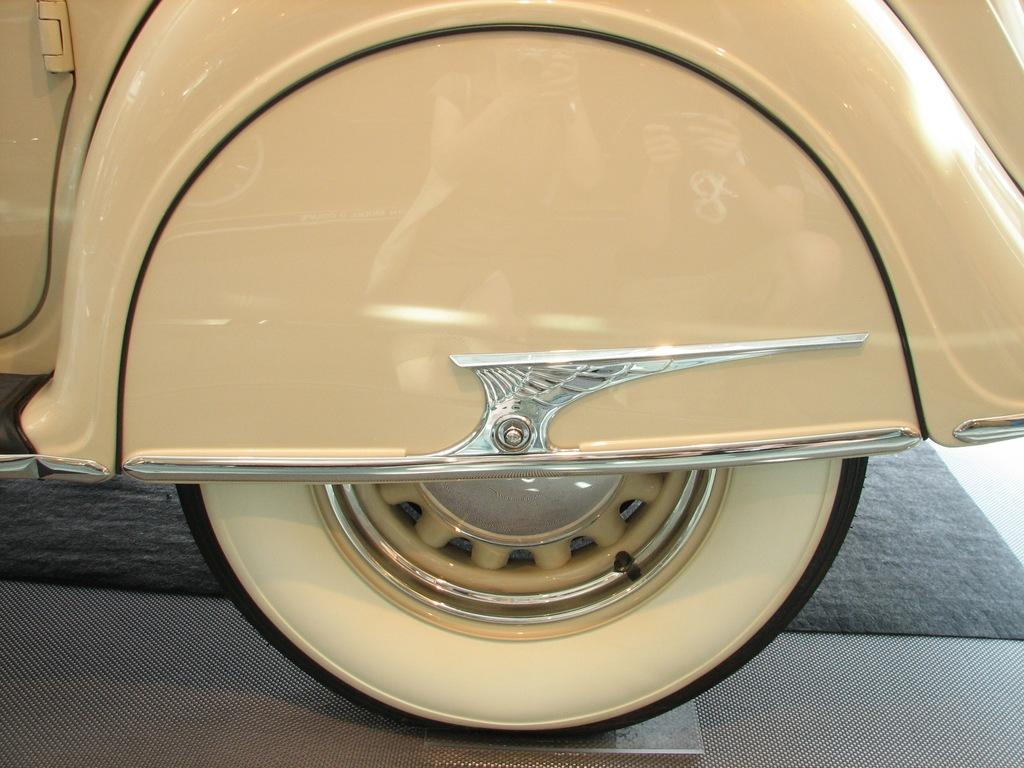What is the main focus of the image? The main focus of the image is a vehicle's tyre. Can you describe the color of the vehicle's body? The body of the vehicle is in cream color. What type of sofa is visible in the image? There is no sofa present in the image; it features a vehicle's tyre and information about the vehicle's body color. 